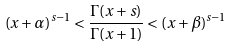<formula> <loc_0><loc_0><loc_500><loc_500>( x + \alpha ) ^ { s - 1 } < \frac { \Gamma ( x + s ) } { \Gamma ( x + 1 ) } < ( x + \beta ) ^ { s - 1 }</formula> 